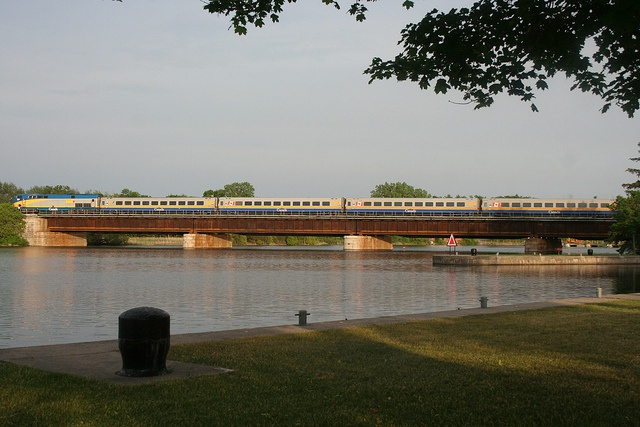Describe the objects in this image and their specific colors. I can see a train in darkgray, gray, and tan tones in this image. 